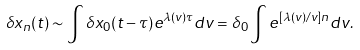<formula> <loc_0><loc_0><loc_500><loc_500>\delta x _ { n } ( t ) \sim \int \delta x _ { 0 } ( t - \tau ) e ^ { \lambda ( v ) \tau } d v = \delta _ { 0 } \int e ^ { [ \lambda ( v ) / v ] n } d v .</formula> 